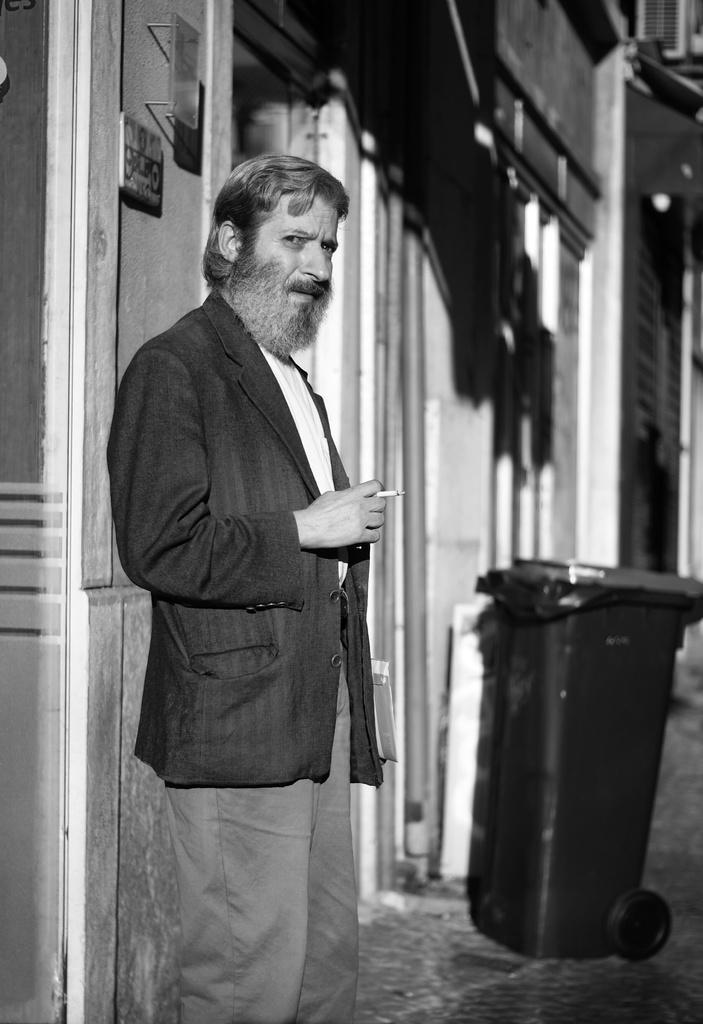What is the person in the image doing? The person is standing in the image and holding a cigarette. What can be seen in the background of the image? There is a building in the background of the image. What is attached to the building? Boards are attached to the building. What is on the ground in the image? There is a dustbin on the ground in the image. What type of rice is being cooked in the image? There is no rice present in the image. What flavor of egg is being prepared in the image? There is no egg present in the image. 